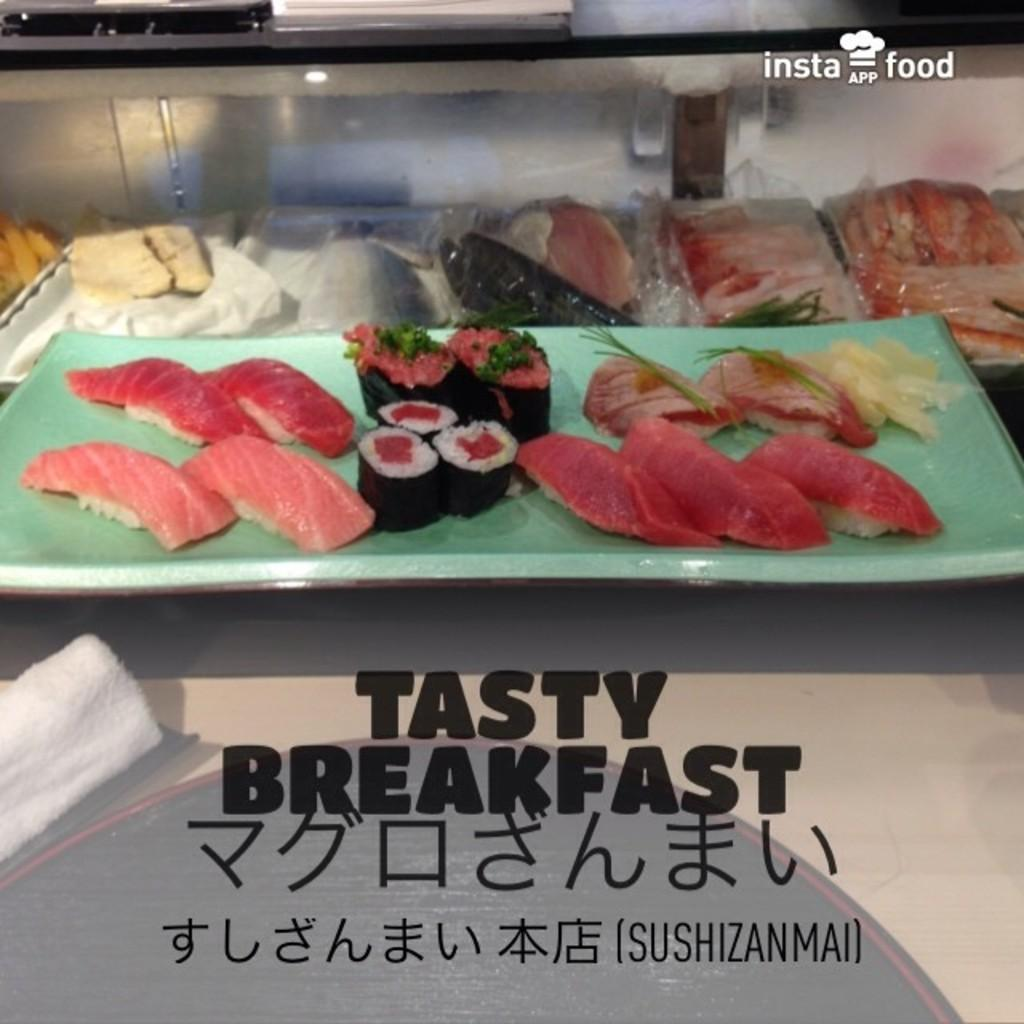What objects are present in the image that hold food or other items? There are trays in the image. What can be found on the trays? The trays contain dishes. Is there any text or information on the trays? Yes, there is writing at the bottom of the trays. How many bears are sitting on the trays in the image? There are no bears present in the image. What type of smile can be seen on the dishes in the image? There is no smile depicted on the dishes in the image. 